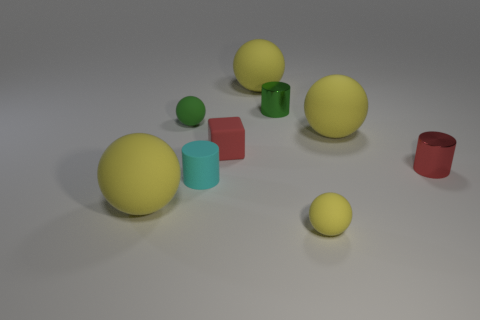What is the shape of the tiny red thing that is on the left side of the tiny rubber object in front of the large matte sphere on the left side of the red matte object? cube 